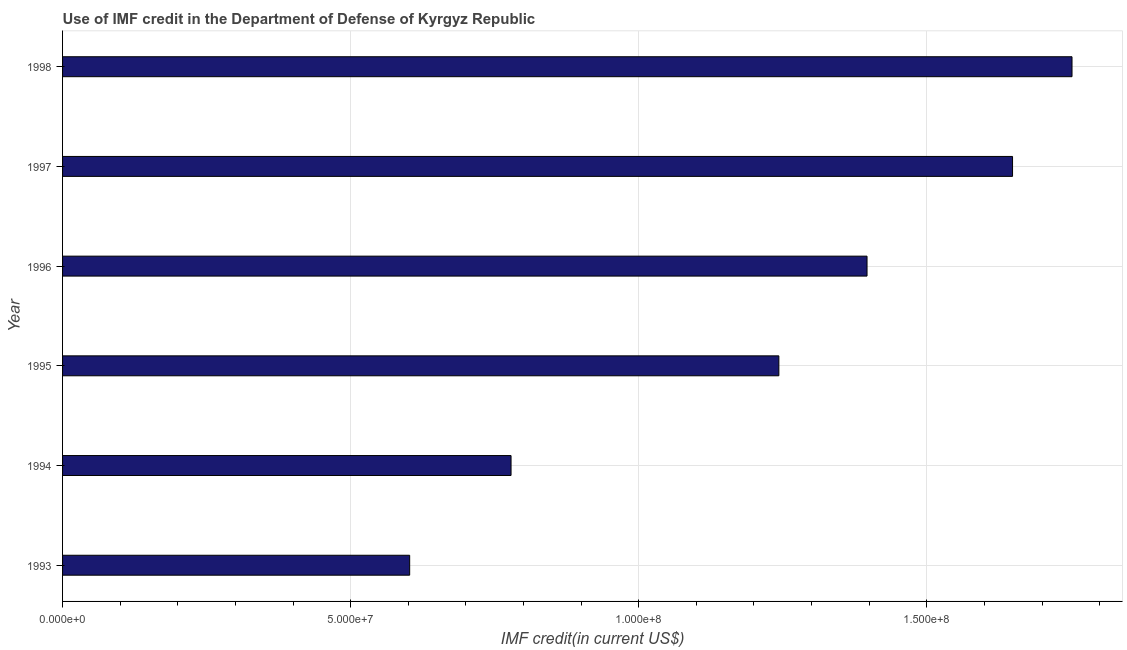Does the graph contain any zero values?
Your answer should be compact. No. Does the graph contain grids?
Offer a very short reply. Yes. What is the title of the graph?
Your response must be concise. Use of IMF credit in the Department of Defense of Kyrgyz Republic. What is the label or title of the X-axis?
Offer a very short reply. IMF credit(in current US$). What is the use of imf credit in dod in 1998?
Offer a terse response. 1.75e+08. Across all years, what is the maximum use of imf credit in dod?
Offer a terse response. 1.75e+08. Across all years, what is the minimum use of imf credit in dod?
Make the answer very short. 6.02e+07. What is the sum of the use of imf credit in dod?
Your answer should be compact. 7.42e+08. What is the difference between the use of imf credit in dod in 1996 and 1998?
Keep it short and to the point. -3.56e+07. What is the average use of imf credit in dod per year?
Your response must be concise. 1.24e+08. What is the median use of imf credit in dod?
Make the answer very short. 1.32e+08. In how many years, is the use of imf credit in dod greater than 170000000 US$?
Your response must be concise. 1. What is the ratio of the use of imf credit in dod in 1994 to that in 1998?
Provide a succinct answer. 0.44. Is the use of imf credit in dod in 1995 less than that in 1996?
Offer a very short reply. Yes. What is the difference between the highest and the second highest use of imf credit in dod?
Your answer should be compact. 1.03e+07. What is the difference between the highest and the lowest use of imf credit in dod?
Provide a short and direct response. 1.15e+08. What is the IMF credit(in current US$) in 1993?
Make the answer very short. 6.02e+07. What is the IMF credit(in current US$) of 1994?
Make the answer very short. 7.78e+07. What is the IMF credit(in current US$) in 1995?
Give a very brief answer. 1.24e+08. What is the IMF credit(in current US$) of 1996?
Offer a terse response. 1.40e+08. What is the IMF credit(in current US$) of 1997?
Give a very brief answer. 1.65e+08. What is the IMF credit(in current US$) of 1998?
Keep it short and to the point. 1.75e+08. What is the difference between the IMF credit(in current US$) in 1993 and 1994?
Offer a terse response. -1.76e+07. What is the difference between the IMF credit(in current US$) in 1993 and 1995?
Offer a terse response. -6.41e+07. What is the difference between the IMF credit(in current US$) in 1993 and 1996?
Your answer should be very brief. -7.94e+07. What is the difference between the IMF credit(in current US$) in 1993 and 1997?
Provide a succinct answer. -1.05e+08. What is the difference between the IMF credit(in current US$) in 1993 and 1998?
Offer a terse response. -1.15e+08. What is the difference between the IMF credit(in current US$) in 1994 and 1995?
Ensure brevity in your answer.  -4.65e+07. What is the difference between the IMF credit(in current US$) in 1994 and 1996?
Your answer should be compact. -6.18e+07. What is the difference between the IMF credit(in current US$) in 1994 and 1997?
Your answer should be very brief. -8.70e+07. What is the difference between the IMF credit(in current US$) in 1994 and 1998?
Keep it short and to the point. -9.74e+07. What is the difference between the IMF credit(in current US$) in 1995 and 1996?
Offer a terse response. -1.53e+07. What is the difference between the IMF credit(in current US$) in 1995 and 1997?
Offer a very short reply. -4.06e+07. What is the difference between the IMF credit(in current US$) in 1995 and 1998?
Give a very brief answer. -5.09e+07. What is the difference between the IMF credit(in current US$) in 1996 and 1997?
Keep it short and to the point. -2.53e+07. What is the difference between the IMF credit(in current US$) in 1996 and 1998?
Make the answer very short. -3.56e+07. What is the difference between the IMF credit(in current US$) in 1997 and 1998?
Provide a short and direct response. -1.03e+07. What is the ratio of the IMF credit(in current US$) in 1993 to that in 1994?
Give a very brief answer. 0.77. What is the ratio of the IMF credit(in current US$) in 1993 to that in 1995?
Offer a terse response. 0.48. What is the ratio of the IMF credit(in current US$) in 1993 to that in 1996?
Offer a very short reply. 0.43. What is the ratio of the IMF credit(in current US$) in 1993 to that in 1997?
Give a very brief answer. 0.36. What is the ratio of the IMF credit(in current US$) in 1993 to that in 1998?
Your answer should be compact. 0.34. What is the ratio of the IMF credit(in current US$) in 1994 to that in 1995?
Make the answer very short. 0.63. What is the ratio of the IMF credit(in current US$) in 1994 to that in 1996?
Provide a short and direct response. 0.56. What is the ratio of the IMF credit(in current US$) in 1994 to that in 1997?
Your response must be concise. 0.47. What is the ratio of the IMF credit(in current US$) in 1994 to that in 1998?
Provide a short and direct response. 0.44. What is the ratio of the IMF credit(in current US$) in 1995 to that in 1996?
Offer a very short reply. 0.89. What is the ratio of the IMF credit(in current US$) in 1995 to that in 1997?
Offer a very short reply. 0.75. What is the ratio of the IMF credit(in current US$) in 1995 to that in 1998?
Your answer should be compact. 0.71. What is the ratio of the IMF credit(in current US$) in 1996 to that in 1997?
Your answer should be compact. 0.85. What is the ratio of the IMF credit(in current US$) in 1996 to that in 1998?
Provide a short and direct response. 0.8. What is the ratio of the IMF credit(in current US$) in 1997 to that in 1998?
Give a very brief answer. 0.94. 